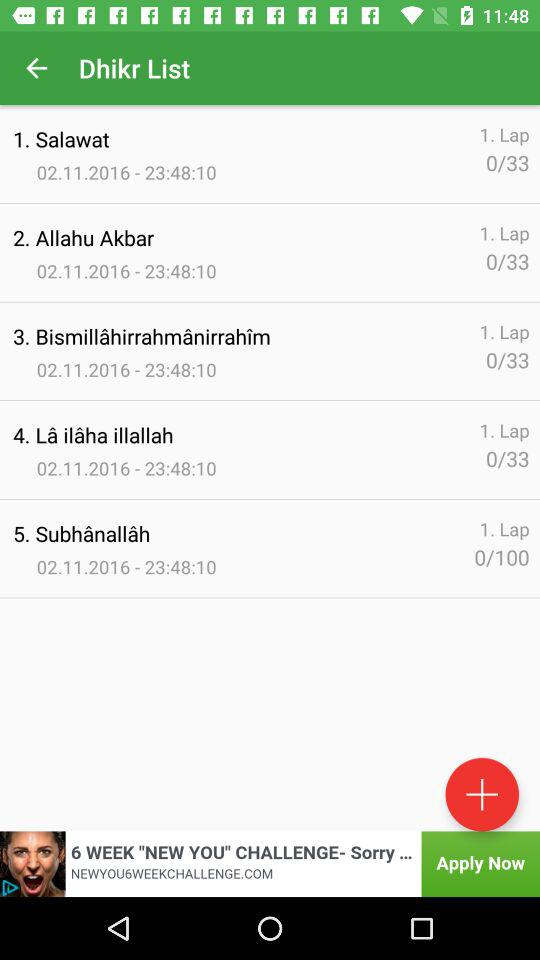How many laps are there for Allahu Akbar? There are 0/33 laps for Allahu Akbar. 